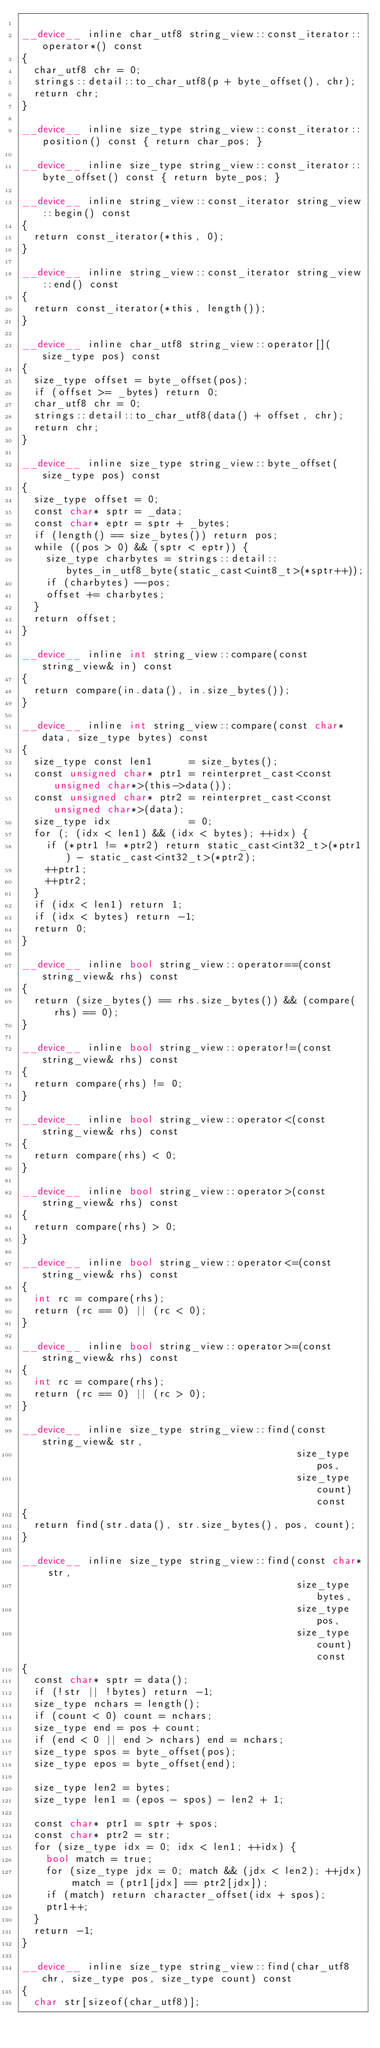<code> <loc_0><loc_0><loc_500><loc_500><_Cuda_>
__device__ inline char_utf8 string_view::const_iterator::operator*() const
{
  char_utf8 chr = 0;
  strings::detail::to_char_utf8(p + byte_offset(), chr);
  return chr;
}

__device__ inline size_type string_view::const_iterator::position() const { return char_pos; }

__device__ inline size_type string_view::const_iterator::byte_offset() const { return byte_pos; }

__device__ inline string_view::const_iterator string_view::begin() const
{
  return const_iterator(*this, 0);
}

__device__ inline string_view::const_iterator string_view::end() const
{
  return const_iterator(*this, length());
}

__device__ inline char_utf8 string_view::operator[](size_type pos) const
{
  size_type offset = byte_offset(pos);
  if (offset >= _bytes) return 0;
  char_utf8 chr = 0;
  strings::detail::to_char_utf8(data() + offset, chr);
  return chr;
}

__device__ inline size_type string_view::byte_offset(size_type pos) const
{
  size_type offset = 0;
  const char* sptr = _data;
  const char* eptr = sptr + _bytes;
  if (length() == size_bytes()) return pos;
  while ((pos > 0) && (sptr < eptr)) {
    size_type charbytes = strings::detail::bytes_in_utf8_byte(static_cast<uint8_t>(*sptr++));
    if (charbytes) --pos;
    offset += charbytes;
  }
  return offset;
}

__device__ inline int string_view::compare(const string_view& in) const
{
  return compare(in.data(), in.size_bytes());
}

__device__ inline int string_view::compare(const char* data, size_type bytes) const
{
  size_type const len1      = size_bytes();
  const unsigned char* ptr1 = reinterpret_cast<const unsigned char*>(this->data());
  const unsigned char* ptr2 = reinterpret_cast<const unsigned char*>(data);
  size_type idx             = 0;
  for (; (idx < len1) && (idx < bytes); ++idx) {
    if (*ptr1 != *ptr2) return static_cast<int32_t>(*ptr1) - static_cast<int32_t>(*ptr2);
    ++ptr1;
    ++ptr2;
  }
  if (idx < len1) return 1;
  if (idx < bytes) return -1;
  return 0;
}

__device__ inline bool string_view::operator==(const string_view& rhs) const
{
  return (size_bytes() == rhs.size_bytes()) && (compare(rhs) == 0);
}

__device__ inline bool string_view::operator!=(const string_view& rhs) const
{
  return compare(rhs) != 0;
}

__device__ inline bool string_view::operator<(const string_view& rhs) const
{
  return compare(rhs) < 0;
}

__device__ inline bool string_view::operator>(const string_view& rhs) const
{
  return compare(rhs) > 0;
}

__device__ inline bool string_view::operator<=(const string_view& rhs) const
{
  int rc = compare(rhs);
  return (rc == 0) || (rc < 0);
}

__device__ inline bool string_view::operator>=(const string_view& rhs) const
{
  int rc = compare(rhs);
  return (rc == 0) || (rc > 0);
}

__device__ inline size_type string_view::find(const string_view& str,
                                              size_type pos,
                                              size_type count) const
{
  return find(str.data(), str.size_bytes(), pos, count);
}

__device__ inline size_type string_view::find(const char* str,
                                              size_type bytes,
                                              size_type pos,
                                              size_type count) const
{
  const char* sptr = data();
  if (!str || !bytes) return -1;
  size_type nchars = length();
  if (count < 0) count = nchars;
  size_type end = pos + count;
  if (end < 0 || end > nchars) end = nchars;
  size_type spos = byte_offset(pos);
  size_type epos = byte_offset(end);

  size_type len2 = bytes;
  size_type len1 = (epos - spos) - len2 + 1;

  const char* ptr1 = sptr + spos;
  const char* ptr2 = str;
  for (size_type idx = 0; idx < len1; ++idx) {
    bool match = true;
    for (size_type jdx = 0; match && (jdx < len2); ++jdx) match = (ptr1[jdx] == ptr2[jdx]);
    if (match) return character_offset(idx + spos);
    ptr1++;
  }
  return -1;
}

__device__ inline size_type string_view::find(char_utf8 chr, size_type pos, size_type count) const
{
  char str[sizeof(char_utf8)];</code> 